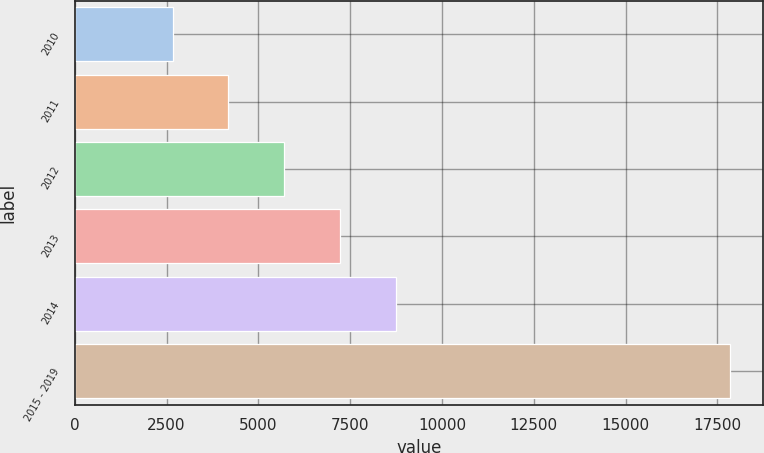<chart> <loc_0><loc_0><loc_500><loc_500><bar_chart><fcel>2010<fcel>2011<fcel>2012<fcel>2013<fcel>2014<fcel>2015 - 2019<nl><fcel>2665<fcel>4182.8<fcel>5700.6<fcel>7218.4<fcel>8736.2<fcel>17843<nl></chart> 